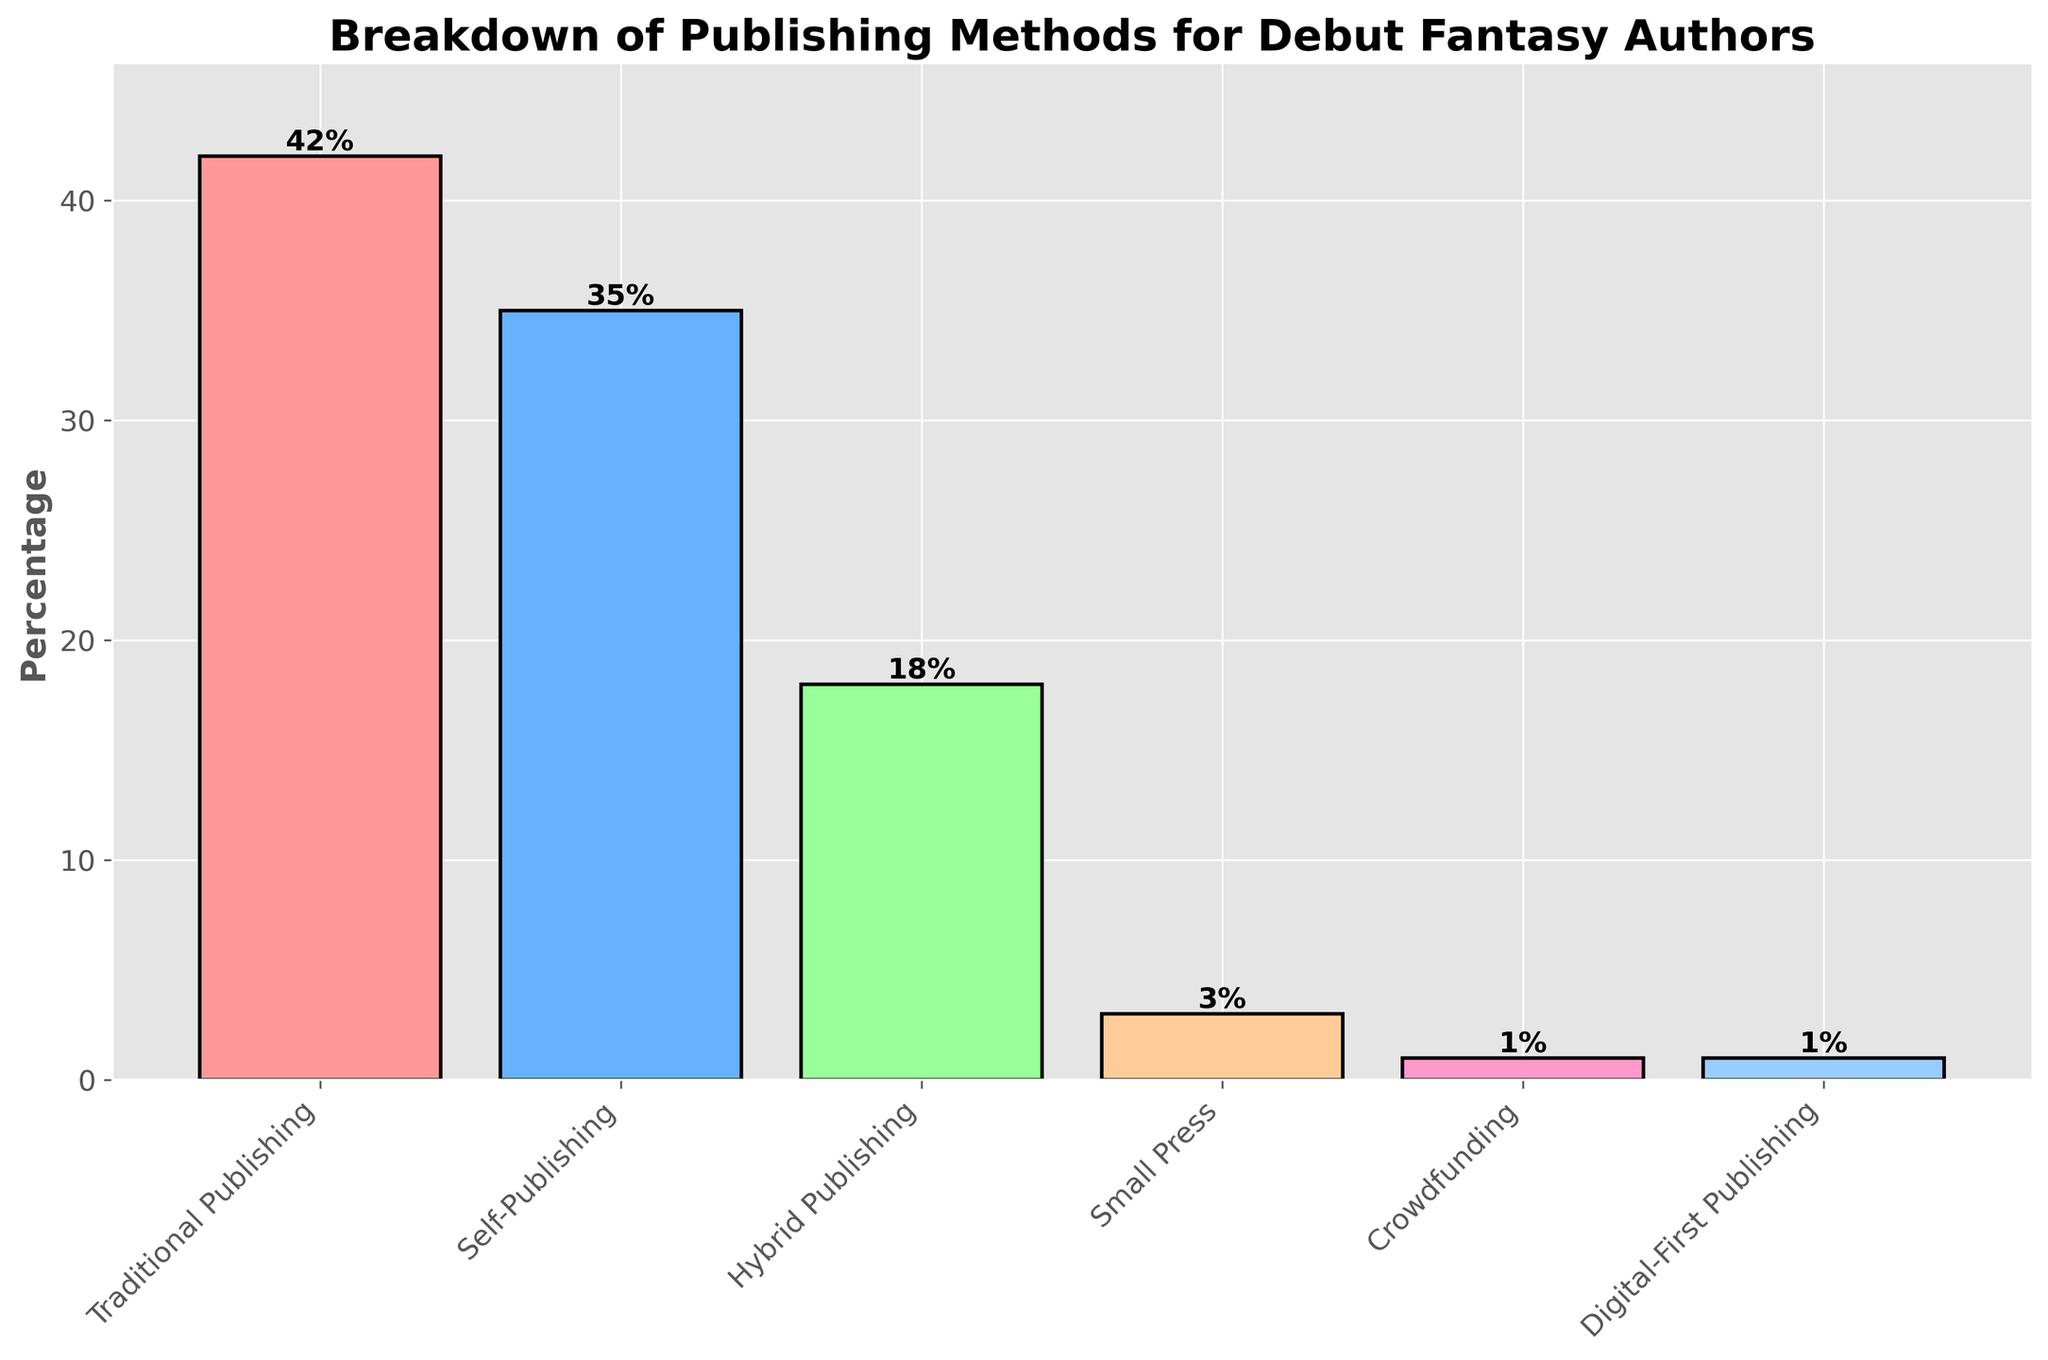what is the most common publishing method among debut fantasy authors? The highest bar represents the traditional publishing method. Since it reaches the maximum height among all bars, it indicates the highest percentage, making it the most common.
Answer: traditional publishing how much more common is traditional publishing compared to hybrid publishing? Traditional publishing has a percentage of 42%, while hybrid publishing has 18%. The difference is calculated as 42% - 18% = 24%.
Answer: 24% combining traditional and self-publishing methods, what percentage of the debut fantasy authors use these methods? The traditional publishing method is 42%, and self-publishing is 35%. Their combined percentage is 42% + 35% = 77%.
Answer: 77% which publishing method has the smallest percentage of debut fantasy authors? The smallest bar is the one representing digital-first publishing and crowdfunding, each at 1%. They are the least common methods.
Answer: digital-first publishing and crowdfunding what is the average percentage of all publishing methods? Sum all the percentages (42 + 35 + 18 + 3 + 1 + 1 = 100). There are six methods, so the average is 100 / 6 ≈ 16.67%.
Answer: 16.67% how do small press and crowdfunding methods combined compare to self-publishing in percentage? Small press is 3%, and crowdfunding is 1%. Their total is 3% + 1% = 4%. Self-publishing is 35%, so 4% compared to 35% is significantly smaller.
Answer: less than self-publishing what percentage of the debut fantasy authors use non-traditional methods (excluding traditional publishing)? Sum the percentages of all other methods (35 + 18 + 3 + 1 + 1 = 58%).
Answer: 58% which method has a bar color that stands out as distinct and is the third most common method? The third tallest bar, representing hybrid publishing (18%), is green, making it distinct.
Answer: hybrid publishing how many publishing methods have a percentage greater than 10%? Traditional publishing (42%), self-publishing (35%), and hybrid publishing (18%) have percentages greater than 10%. So, there are three methods.
Answer: three if you combine hybrid, small press, crowdfunding, and digital-first publishing, is their total percentage greater than self-publishing? Hybrid (18%), small press (3%), crowdfunding (1%), and digital-first (1%) together make 18% + 3% + 1% + 1% = 23%, which is less than self-publishing's 35%.
Answer: no 